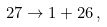Convert formula to latex. <formula><loc_0><loc_0><loc_500><loc_500>2 7 \rightarrow 1 + 2 6 \, ,</formula> 